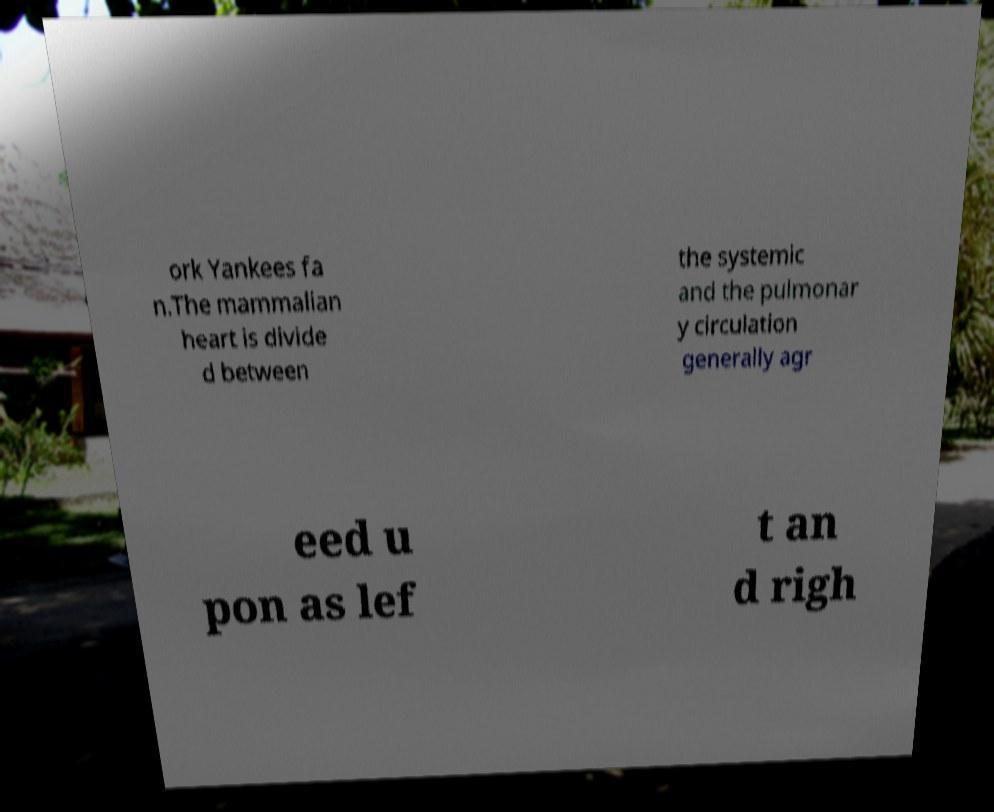Please read and relay the text visible in this image. What does it say? ork Yankees fa n.The mammalian heart is divide d between the systemic and the pulmonar y circulation generally agr eed u pon as lef t an d righ 